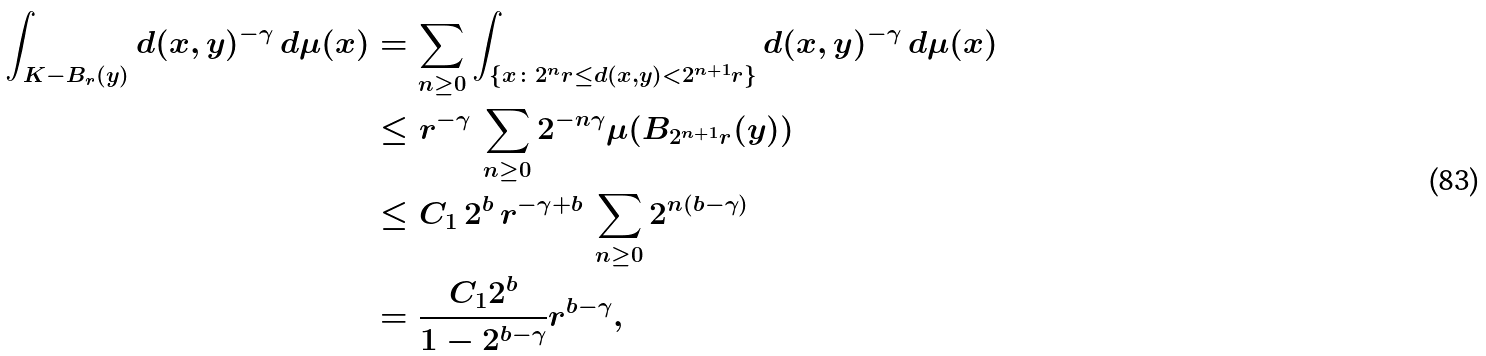<formula> <loc_0><loc_0><loc_500><loc_500>\int _ { K - B _ { r } ( y ) } d ( x , y ) ^ { - \gamma } \, d \mu ( x ) & = \sum _ { n \geq 0 } \int _ { \{ x \colon 2 ^ { n } r \leq d ( x , y ) < 2 ^ { n + 1 } r \} } d ( x , y ) ^ { - \gamma } \, d \mu ( x ) \\ & \leq r ^ { - \gamma } \, \sum _ { n \geq 0 } 2 ^ { - n \gamma } \mu ( B _ { 2 ^ { n + 1 } r } ( y ) ) \\ & \leq C _ { 1 } \, 2 ^ { b } \, r ^ { - \gamma + b } \, \sum _ { n \geq 0 } 2 ^ { n ( b - \gamma ) } \\ & = \frac { C _ { 1 } 2 ^ { b } } { 1 - 2 ^ { b - \gamma } } r ^ { b - \gamma } ,</formula> 